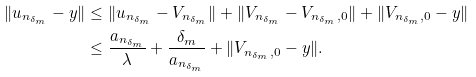Convert formula to latex. <formula><loc_0><loc_0><loc_500><loc_500>\| u _ { n _ { \delta _ { m } } } - y \| & \leq \| u _ { n _ { \delta _ { m } } } - V _ { n _ { \delta _ { m } } } \| + \| V _ { n _ { \delta _ { m } } } - V _ { { n _ { \delta _ { m } } } , 0 } \| + \| V _ { { n _ { \delta _ { m } } } , 0 } - y \| \\ & \leq \frac { a _ { n _ { \delta _ { m } } } } { \lambda } + \frac { \delta _ { m } } { a _ { n _ { \delta _ { m } } } } + \| V _ { { n _ { \delta _ { m } } } , 0 } - y \| .</formula> 